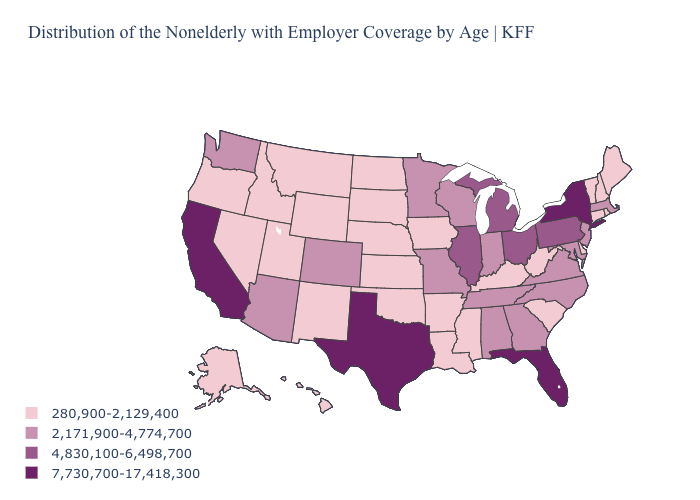Among the states that border Oklahoma , does Texas have the highest value?
Short answer required. Yes. What is the value of Virginia?
Quick response, please. 2,171,900-4,774,700. Name the states that have a value in the range 4,830,100-6,498,700?
Quick response, please. Illinois, Michigan, Ohio, Pennsylvania. What is the value of Utah?
Write a very short answer. 280,900-2,129,400. What is the value of Vermont?
Be succinct. 280,900-2,129,400. What is the value of Washington?
Write a very short answer. 2,171,900-4,774,700. What is the value of Connecticut?
Quick response, please. 280,900-2,129,400. What is the value of Arkansas?
Quick response, please. 280,900-2,129,400. Name the states that have a value in the range 280,900-2,129,400?
Give a very brief answer. Alaska, Arkansas, Connecticut, Delaware, Hawaii, Idaho, Iowa, Kansas, Kentucky, Louisiana, Maine, Mississippi, Montana, Nebraska, Nevada, New Hampshire, New Mexico, North Dakota, Oklahoma, Oregon, Rhode Island, South Carolina, South Dakota, Utah, Vermont, West Virginia, Wyoming. What is the value of Alabama?
Keep it brief. 2,171,900-4,774,700. What is the value of Rhode Island?
Concise answer only. 280,900-2,129,400. What is the highest value in the USA?
Write a very short answer. 7,730,700-17,418,300. What is the lowest value in the USA?
Keep it brief. 280,900-2,129,400. What is the lowest value in the MidWest?
Keep it brief. 280,900-2,129,400. What is the value of Oklahoma?
Be succinct. 280,900-2,129,400. 